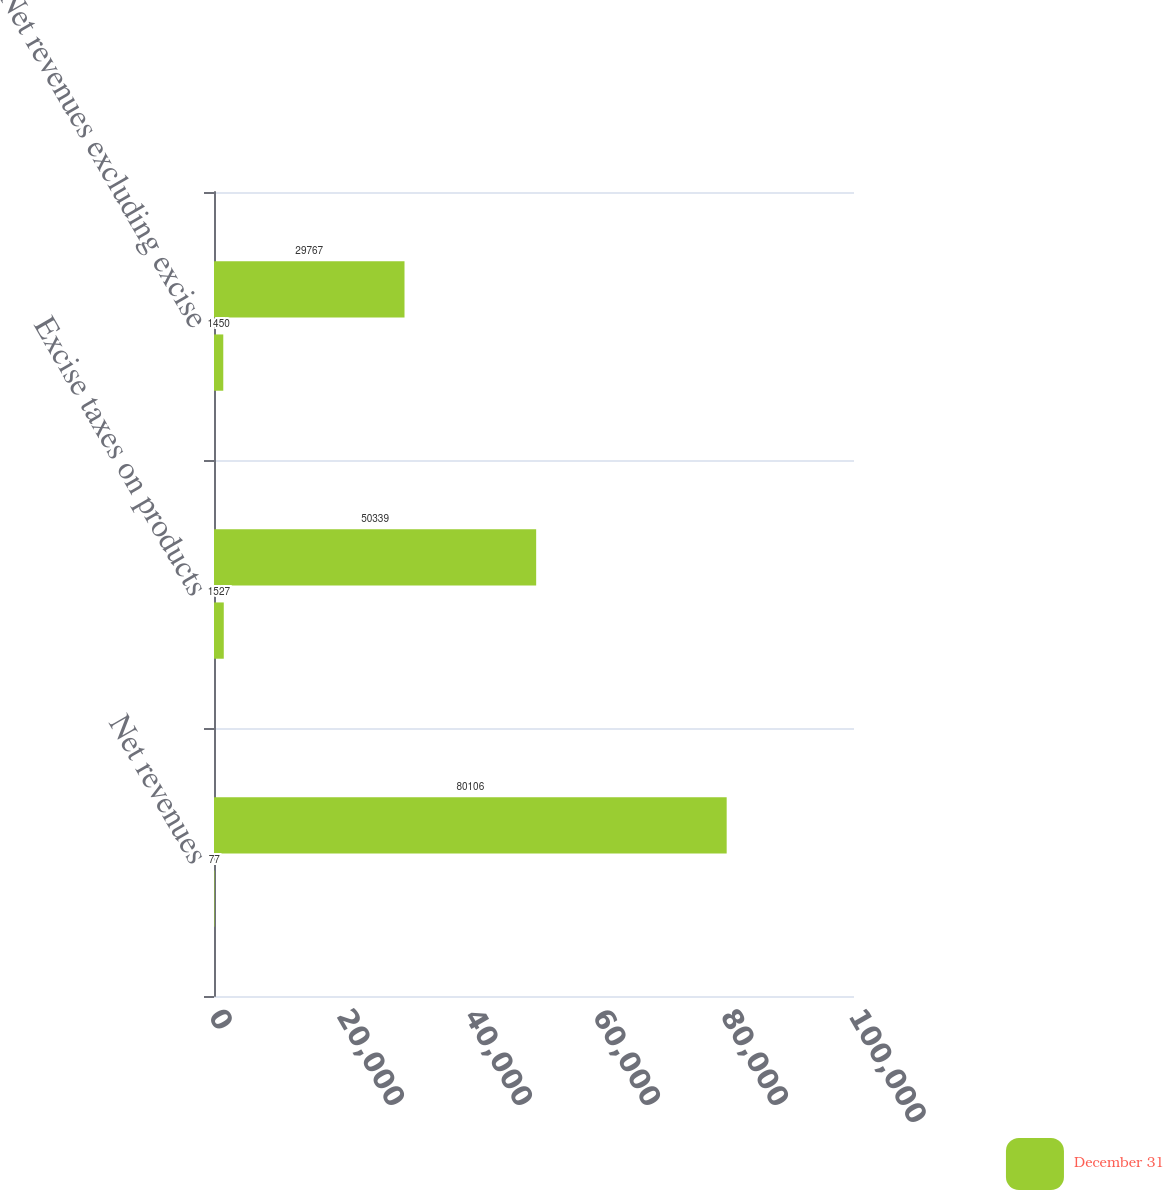Convert chart. <chart><loc_0><loc_0><loc_500><loc_500><stacked_bar_chart><ecel><fcel>Net revenues<fcel>Excise taxes on products<fcel>Net revenues excluding excise<nl><fcel>nan<fcel>80106<fcel>50339<fcel>29767<nl><fcel>December 31<fcel>77<fcel>1527<fcel>1450<nl></chart> 